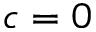Convert formula to latex. <formula><loc_0><loc_0><loc_500><loc_500>c = 0</formula> 